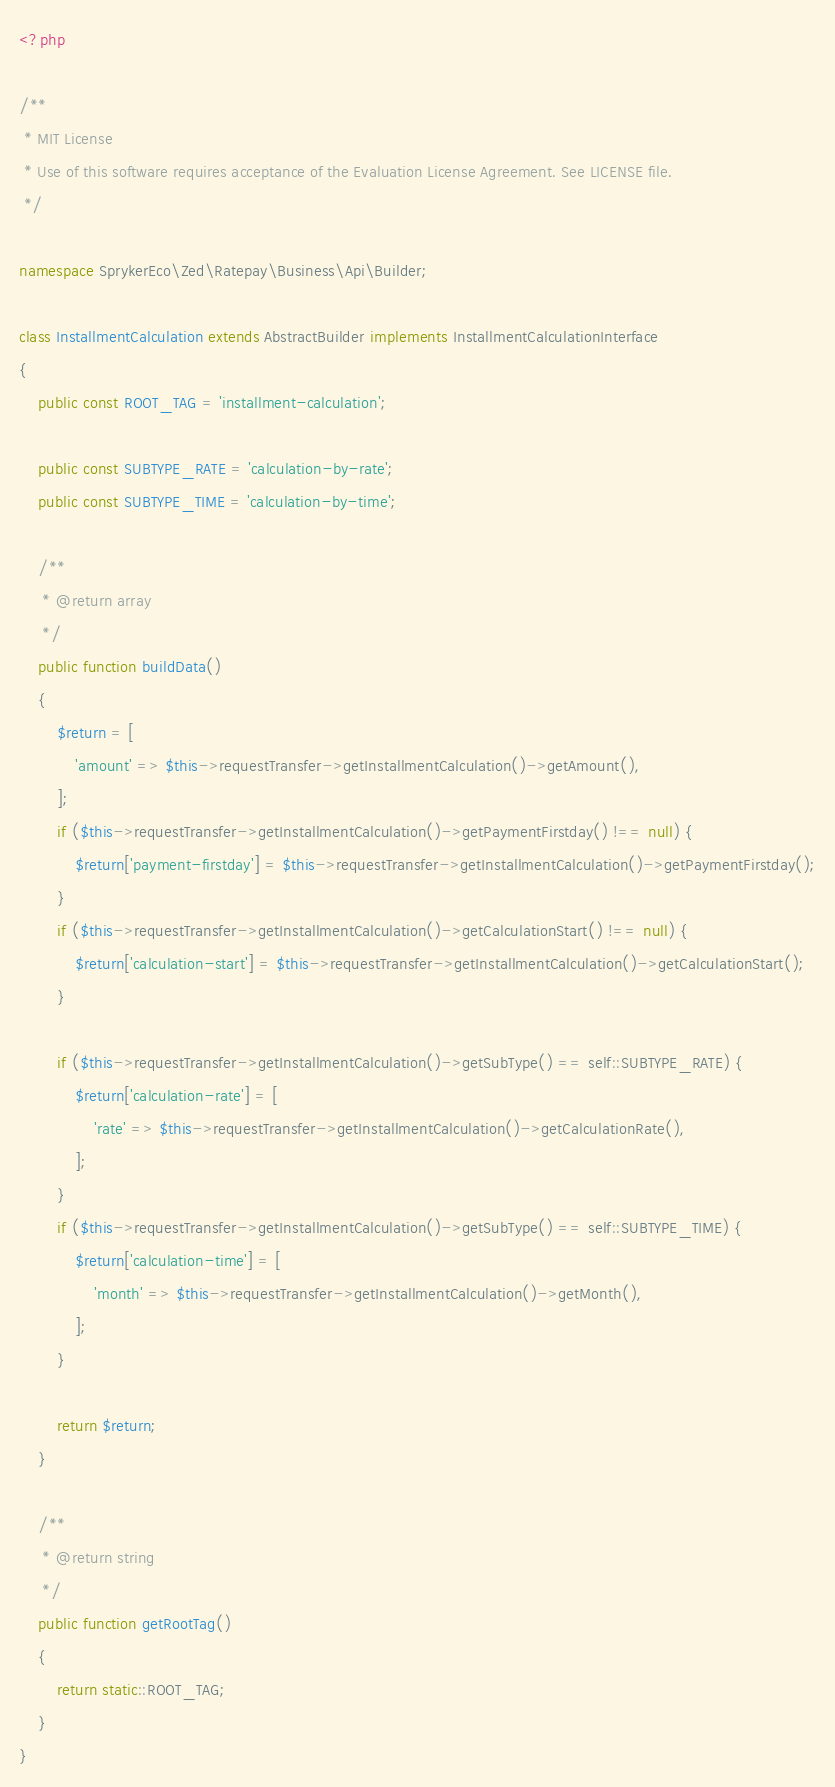<code> <loc_0><loc_0><loc_500><loc_500><_PHP_><?php

/**
 * MIT License
 * Use of this software requires acceptance of the Evaluation License Agreement. See LICENSE file.
 */

namespace SprykerEco\Zed\Ratepay\Business\Api\Builder;

class InstallmentCalculation extends AbstractBuilder implements InstallmentCalculationInterface
{
    public const ROOT_TAG = 'installment-calculation';

    public const SUBTYPE_RATE = 'calculation-by-rate';
    public const SUBTYPE_TIME = 'calculation-by-time';

    /**
     * @return array
     */
    public function buildData()
    {
        $return = [
            'amount' => $this->requestTransfer->getInstallmentCalculation()->getAmount(),
        ];
        if ($this->requestTransfer->getInstallmentCalculation()->getPaymentFirstday() !== null) {
            $return['payment-firstday'] = $this->requestTransfer->getInstallmentCalculation()->getPaymentFirstday();
        }
        if ($this->requestTransfer->getInstallmentCalculation()->getCalculationStart() !== null) {
            $return['calculation-start'] = $this->requestTransfer->getInstallmentCalculation()->getCalculationStart();
        }

        if ($this->requestTransfer->getInstallmentCalculation()->getSubType() == self::SUBTYPE_RATE) {
            $return['calculation-rate'] = [
                'rate' => $this->requestTransfer->getInstallmentCalculation()->getCalculationRate(),
            ];
        }
        if ($this->requestTransfer->getInstallmentCalculation()->getSubType() == self::SUBTYPE_TIME) {
            $return['calculation-time'] = [
                'month' => $this->requestTransfer->getInstallmentCalculation()->getMonth(),
            ];
        }

        return $return;
    }

    /**
     * @return string
     */
    public function getRootTag()
    {
        return static::ROOT_TAG;
    }
}
</code> 